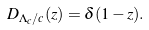<formula> <loc_0><loc_0><loc_500><loc_500>D _ { \Lambda _ { c } / c } ( z ) = \delta ( 1 - z ) .</formula> 